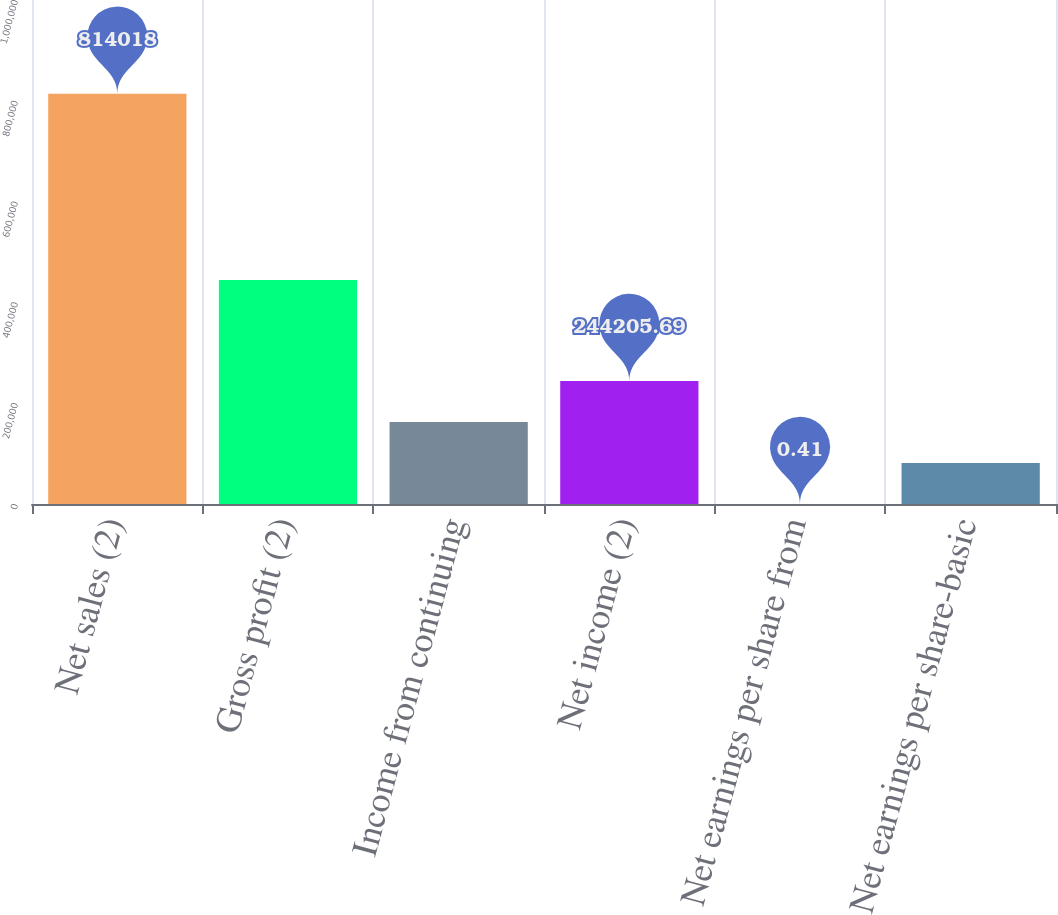Convert chart to OTSL. <chart><loc_0><loc_0><loc_500><loc_500><bar_chart><fcel>Net sales (2)<fcel>Gross profit (2)<fcel>Income from continuing<fcel>Net income (2)<fcel>Net earnings per share from<fcel>Net earnings per share-basic<nl><fcel>814018<fcel>444255<fcel>162804<fcel>244206<fcel>0.41<fcel>81402.2<nl></chart> 